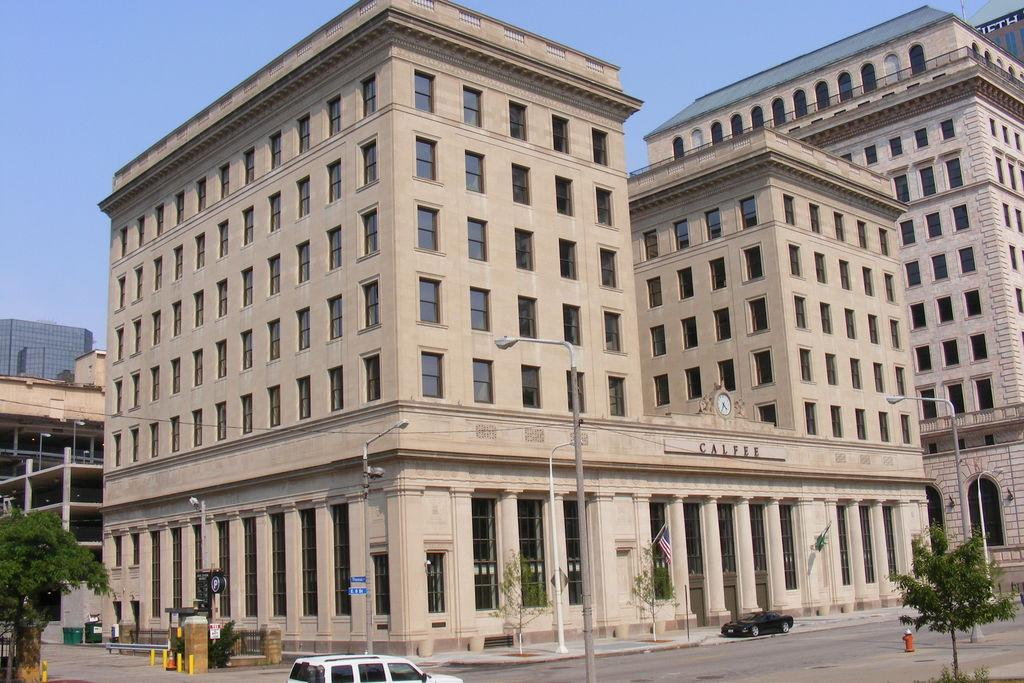What can be seen on the road in the image? There are vehicles on the road in the image. What structures are present along the road? There are light poles in the image. What type of vegetation is visible in the image? There are green trees in the image. What can be seen in the background of the image? There are buildings in the background of the image. What color are the buildings? The buildings are in a cream color. What is the color of the sky in the image? The sky is blue in the image. Where is the lettuce located in the image? There is no lettuce present in the image. What type of police vehicle can be seen in the image? There are no police vehicles present in the image. What utensil is being used to eat the buildings in the image? There are no utensils or eating involved in the image; the buildings are not food. 